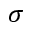Convert formula to latex. <formula><loc_0><loc_0><loc_500><loc_500>\sigma</formula> 